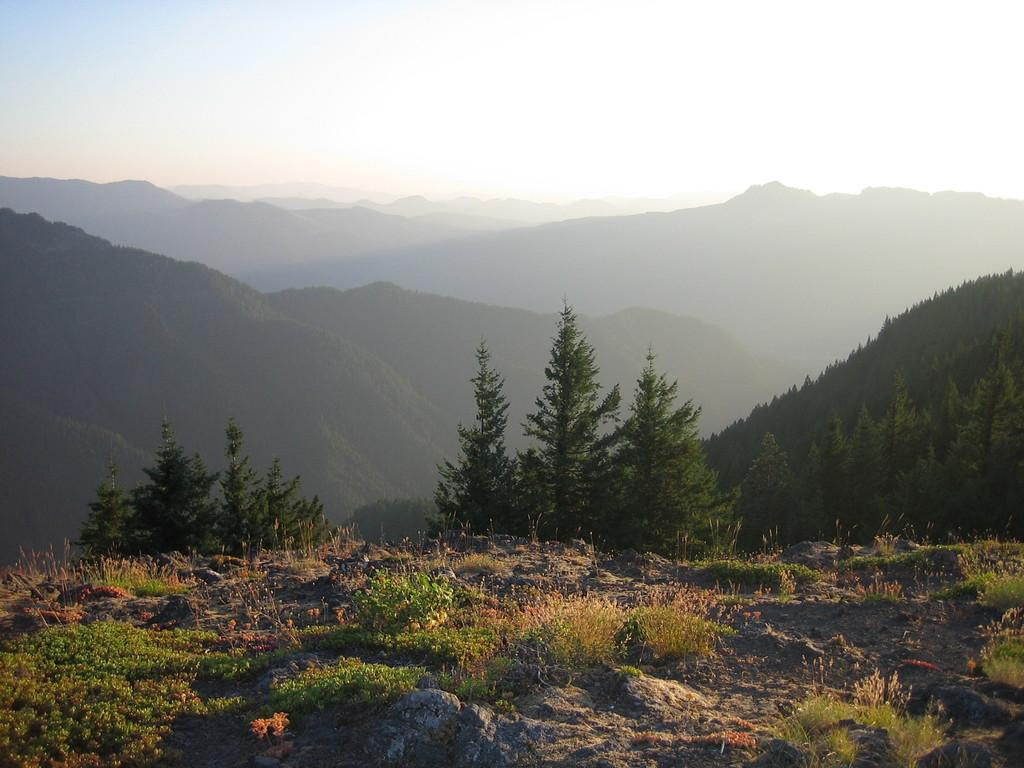What type of vegetation can be seen in the image? There are plants and trees in the image. What geographical feature is visible in the image? There are mountains in the image. What is the ground like in the image? The ground is visible in the image, and it appears to have grass. What part of the natural environment is visible in the image? The sky is visible in the image. What type of nose can be seen on the trees in the image? There are no noses present on the trees in the image; trees do not have noses. 